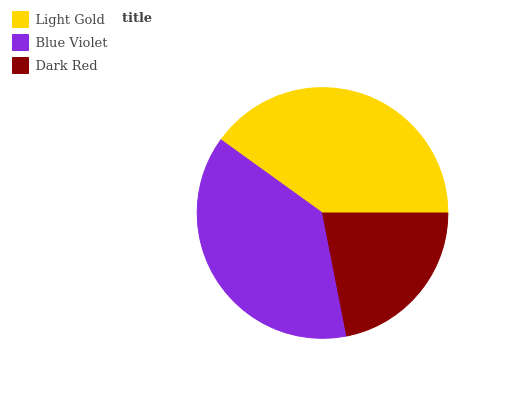Is Dark Red the minimum?
Answer yes or no. Yes. Is Light Gold the maximum?
Answer yes or no. Yes. Is Blue Violet the minimum?
Answer yes or no. No. Is Blue Violet the maximum?
Answer yes or no. No. Is Light Gold greater than Blue Violet?
Answer yes or no. Yes. Is Blue Violet less than Light Gold?
Answer yes or no. Yes. Is Blue Violet greater than Light Gold?
Answer yes or no. No. Is Light Gold less than Blue Violet?
Answer yes or no. No. Is Blue Violet the high median?
Answer yes or no. Yes. Is Blue Violet the low median?
Answer yes or no. Yes. Is Dark Red the high median?
Answer yes or no. No. Is Dark Red the low median?
Answer yes or no. No. 